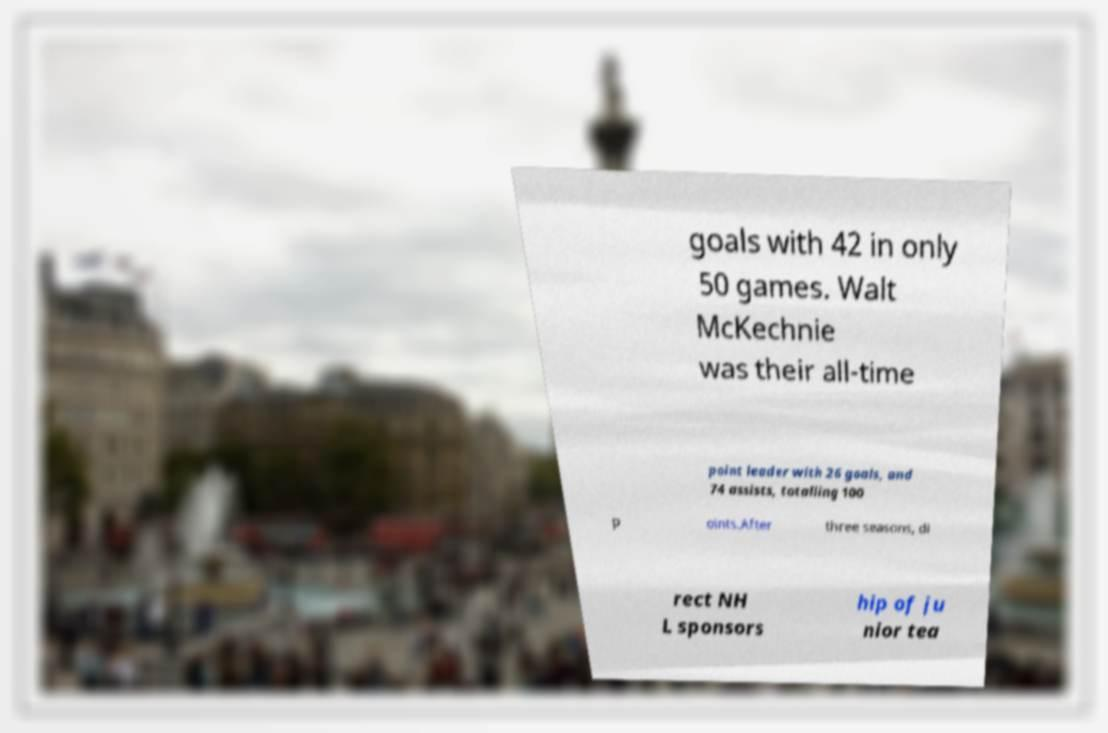Please identify and transcribe the text found in this image. goals with 42 in only 50 games. Walt McKechnie was their all-time point leader with 26 goals, and 74 assists, totalling 100 p oints.After three seasons, di rect NH L sponsors hip of ju nior tea 